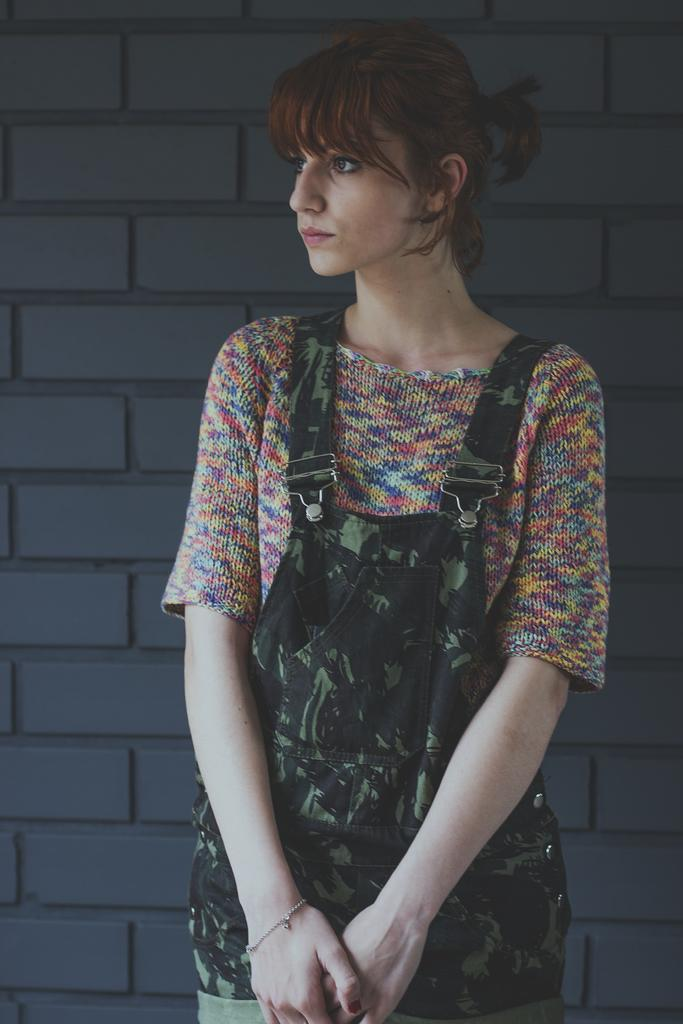What is the color of the wall in the image? The wall in the image is gray. What can be seen in front of the wall in the image? There is a woman standing in front of the wall in the image. What type of coat is the woman wearing in the image? There is no coat visible in the image, as the woman is not wearing any clothing. Can you see any soap in the image? There is no soap present in the image. 